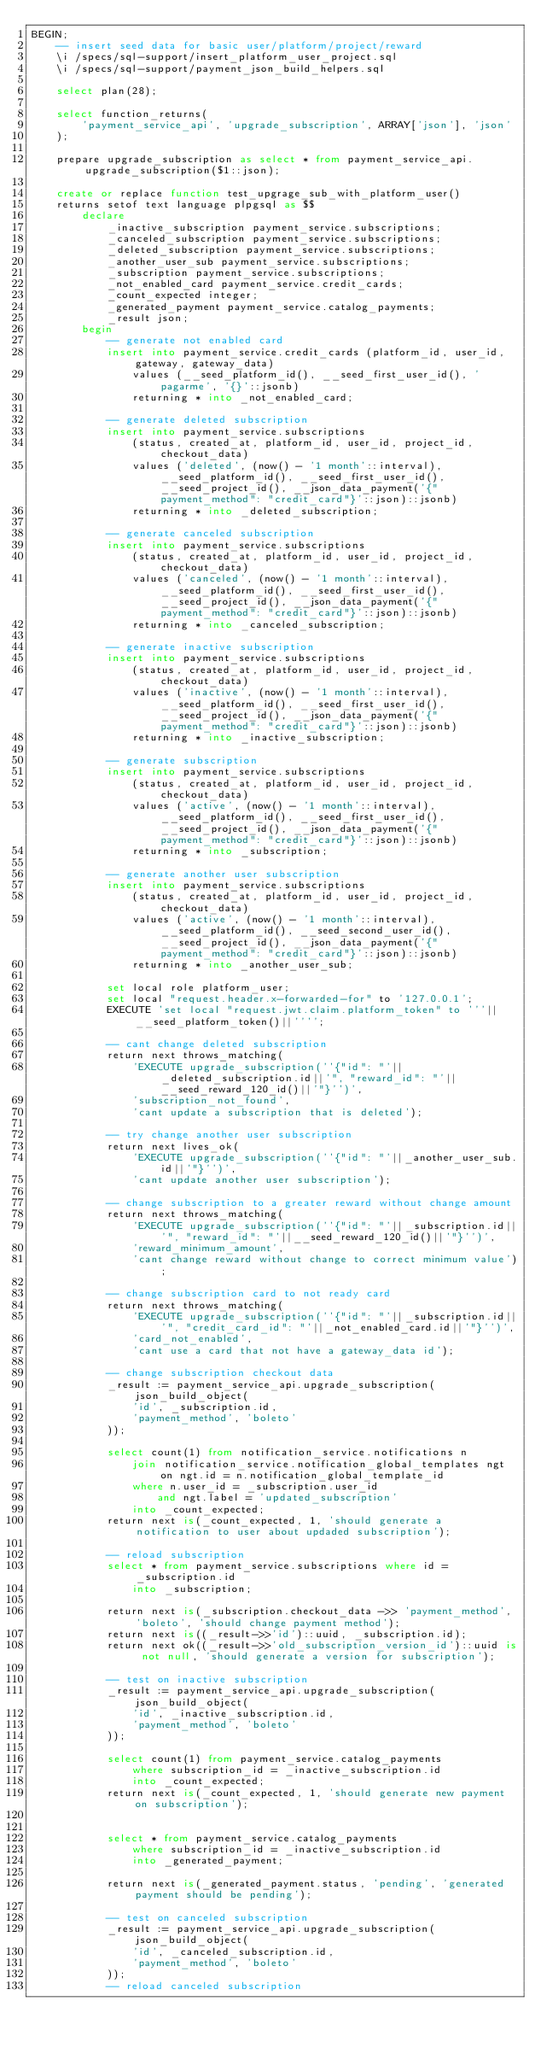<code> <loc_0><loc_0><loc_500><loc_500><_SQL_>BEGIN;
    -- insert seed data for basic user/platform/project/reward
    \i /specs/sql-support/insert_platform_user_project.sql
    \i /specs/sql-support/payment_json_build_helpers.sql

    select plan(28);

    select function_returns(
        'payment_service_api', 'upgrade_subscription', ARRAY['json'], 'json'
    );

    prepare upgrade_subscription as select * from payment_service_api.upgrade_subscription($1::json);

    create or replace function test_upgrage_sub_with_platform_user()
    returns setof text language plpgsql as $$
        declare
            _inactive_subscription payment_service.subscriptions;
            _canceled_subscription payment_service.subscriptions;
            _deleted_subscription payment_service.subscriptions;
            _another_user_sub payment_service.subscriptions;
            _subscription payment_service.subscriptions;
            _not_enabled_card payment_service.credit_cards;
            _count_expected integer;
            _generated_payment payment_service.catalog_payments;
            _result json;
        begin
            -- generate not enabled card
            insert into payment_service.credit_cards (platform_id, user_id, gateway, gateway_data)
                values (__seed_platform_id(), __seed_first_user_id(), 'pagarme', '{}'::jsonb)
                returning * into _not_enabled_card;

            -- generate deleted subscription
            insert into payment_service.subscriptions
                (status, created_at, platform_id, user_id, project_id, checkout_data) 
                values ('deleted', (now() - '1 month'::interval), __seed_platform_id(), __seed_first_user_id(), __seed_project_id(), __json_data_payment('{"payment_method": "credit_card"}'::json)::jsonb)
                returning * into _deleted_subscription;

            -- generate canceled subscription
            insert into payment_service.subscriptions
                (status, created_at, platform_id, user_id, project_id, checkout_data) 
                values ('canceled', (now() - '1 month'::interval), __seed_platform_id(), __seed_first_user_id(), __seed_project_id(), __json_data_payment('{"payment_method": "credit_card"}'::json)::jsonb)
                returning * into _canceled_subscription;

            -- generate inactive subscription
            insert into payment_service.subscriptions
                (status, created_at, platform_id, user_id, project_id, checkout_data) 
                values ('inactive', (now() - '1 month'::interval), __seed_platform_id(), __seed_first_user_id(), __seed_project_id(), __json_data_payment('{"payment_method": "credit_card"}'::json)::jsonb)
                returning * into _inactive_subscription;

            -- generate subscription
            insert into payment_service.subscriptions
                (status, created_at, platform_id, user_id, project_id, checkout_data) 
                values ('active', (now() - '1 month'::interval), __seed_platform_id(), __seed_first_user_id(), __seed_project_id(), __json_data_payment('{"payment_method": "credit_card"}'::json)::jsonb)
                returning * into _subscription;

            -- generate another user subscription
            insert into payment_service.subscriptions
                (status, created_at, platform_id, user_id, project_id, checkout_data) 
                values ('active', (now() - '1 month'::interval), __seed_platform_id(), __seed_second_user_id(), __seed_project_id(), __json_data_payment('{"payment_method": "credit_card"}'::json)::jsonb)
                returning * into _another_user_sub;

            set local role platform_user;
            set local "request.header.x-forwarded-for" to '127.0.0.1';
            EXECUTE 'set local "request.jwt.claim.platform_token" to '''||__seed_platform_token()||'''';

            -- cant change deleted subscription
            return next throws_matching(
                'EXECUTE upgrade_subscription(''{"id": "'||_deleted_subscription.id||'", "reward_id": "'||__seed_reward_120_id()||'"}'')', 
                'subscription_not_found',
                'cant update a subscription that is deleted');

            -- try change another user subscription
            return next lives_ok(
                'EXECUTE upgrade_subscription(''{"id": "'||_another_user_sub.id||'"}'')', 
                'cant update another user subscription');

            -- change subscription to a greater reward without change amount
            return next throws_matching(
                'EXECUTE upgrade_subscription(''{"id": "'||_subscription.id||'", "reward_id": "'||__seed_reward_120_id()||'"}'')', 
                'reward_minimum_amount',
                'cant change reward without change to correct minimum value');

            -- change subscription card to not ready card
            return next throws_matching(
                'EXECUTE upgrade_subscription(''{"id": "'||_subscription.id||'", "credit_card_id": "'||_not_enabled_card.id||'"}'')', 
                'card_not_enabled',
                'cant use a card that not have a gateway_data id');

            -- change subscription checkout data
            _result := payment_service_api.upgrade_subscription(json_build_object(
                'id', _subscription.id,
                'payment_method', 'boleto'
            ));

            select count(1) from notification_service.notifications n
                join notification_service.notification_global_templates ngt on ngt.id = n.notification_global_template_id
                where n.user_id = _subscription.user_id
                    and ngt.label = 'updated_subscription'
                into _count_expected;
            return next is(_count_expected, 1, 'should generate a notification to user about updaded subscription');

            -- reload subscription 
            select * from payment_service.subscriptions where id = _subscription.id
                into _subscription;

            return next is(_subscription.checkout_data ->> 'payment_method', 'boleto', 'should change payment method');
            return next is((_result->>'id')::uuid, _subscription.id);
            return next ok((_result->>'old_subscription_version_id')::uuid is not null, 'should generate a version for subscription');

            -- test on inactive subscription
            _result := payment_service_api.upgrade_subscription(json_build_object(
                'id', _inactive_subscription.id,
                'payment_method', 'boleto'
            ));

            select count(1) from payment_service.catalog_payments
                where subscription_id = _inactive_subscription.id
                into _count_expected;
            return next is(_count_expected, 1, 'should generate new payment on subscription');


            select * from payment_service.catalog_payments
                where subscription_id = _inactive_subscription.id
                into _generated_payment;

            return next is(_generated_payment.status, 'pending', 'generated payment should be pending');

			-- test on canceled subscription
            _result := payment_service_api.upgrade_subscription(json_build_object(
                'id', _canceled_subscription.id,
                'payment_method', 'boleto'
            ));
			-- reload canceled subscription</code> 